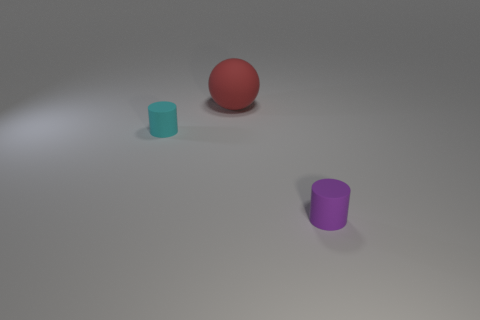Add 2 purple metallic cubes. How many objects exist? 5 Subtract all balls. Subtract all purple matte things. How many objects are left? 1 Add 2 red matte things. How many red matte things are left? 3 Add 1 big red matte things. How many big red matte things exist? 2 Subtract 0 green cylinders. How many objects are left? 3 Subtract all cylinders. How many objects are left? 1 